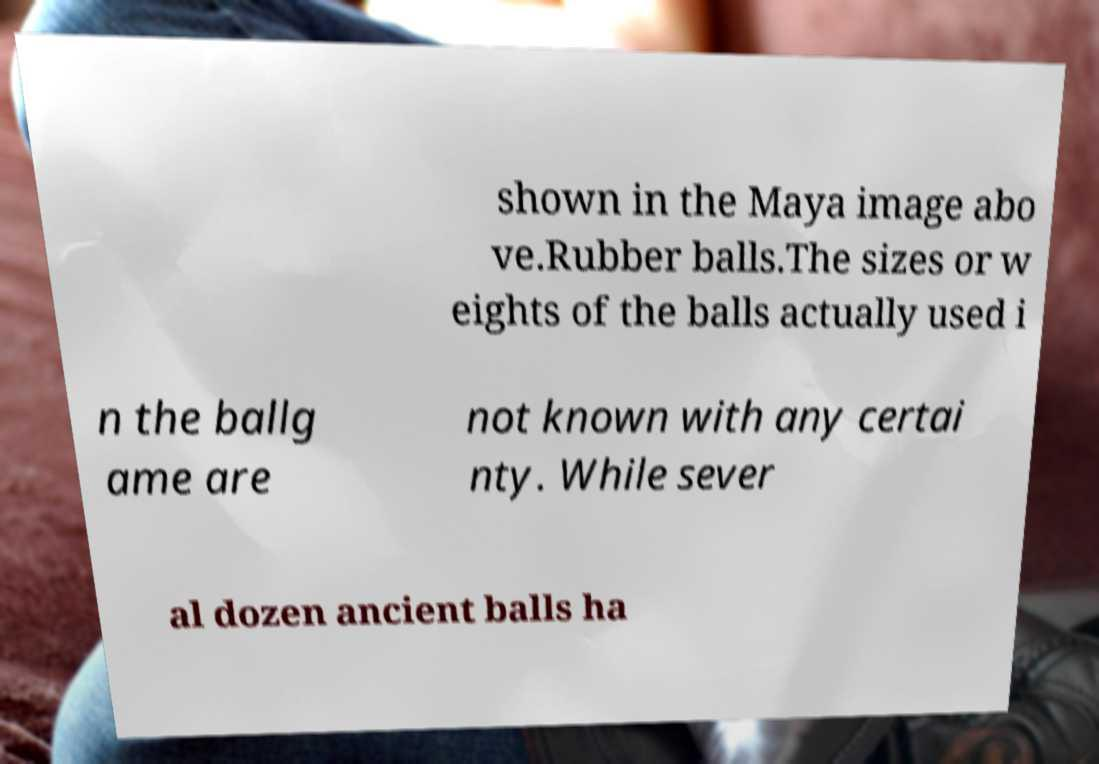Could you assist in decoding the text presented in this image and type it out clearly? shown in the Maya image abo ve.Rubber balls.The sizes or w eights of the balls actually used i n the ballg ame are not known with any certai nty. While sever al dozen ancient balls ha 